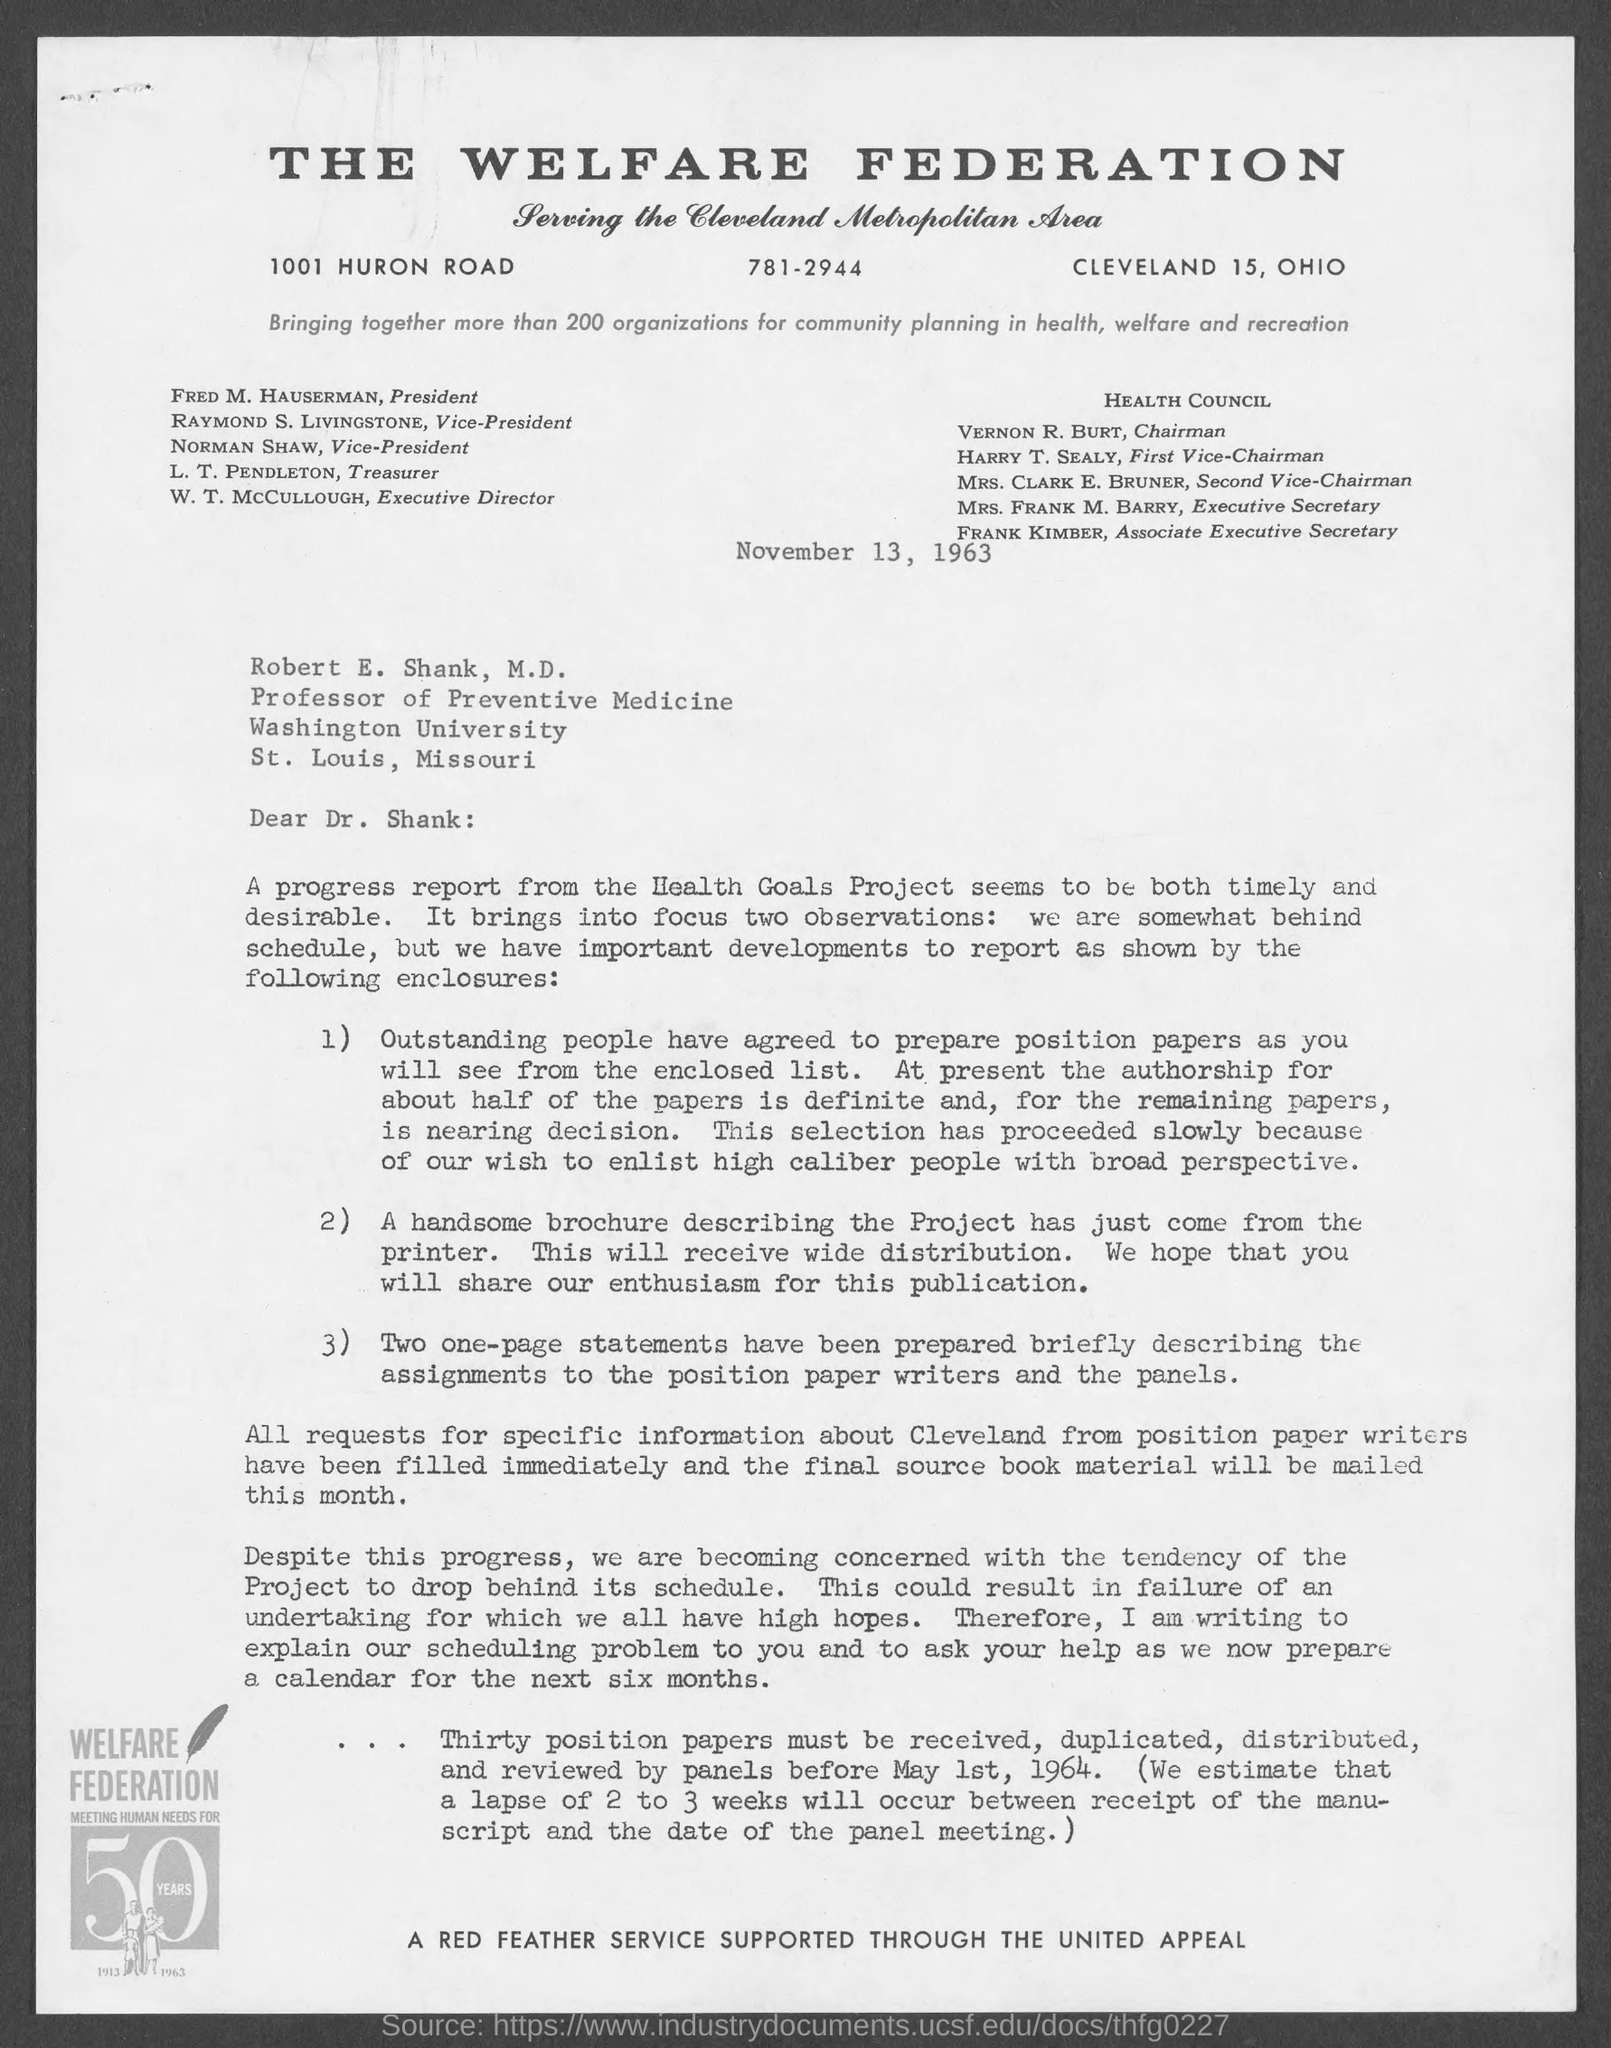Specify some key components in this picture. The Professor of Preventive Medicine is Robert E. Shank, M.D. The President of the welfare federation is Fred M. Hauserman. The Associate Executive Secretary of the Health Council is Frank Kimber. 